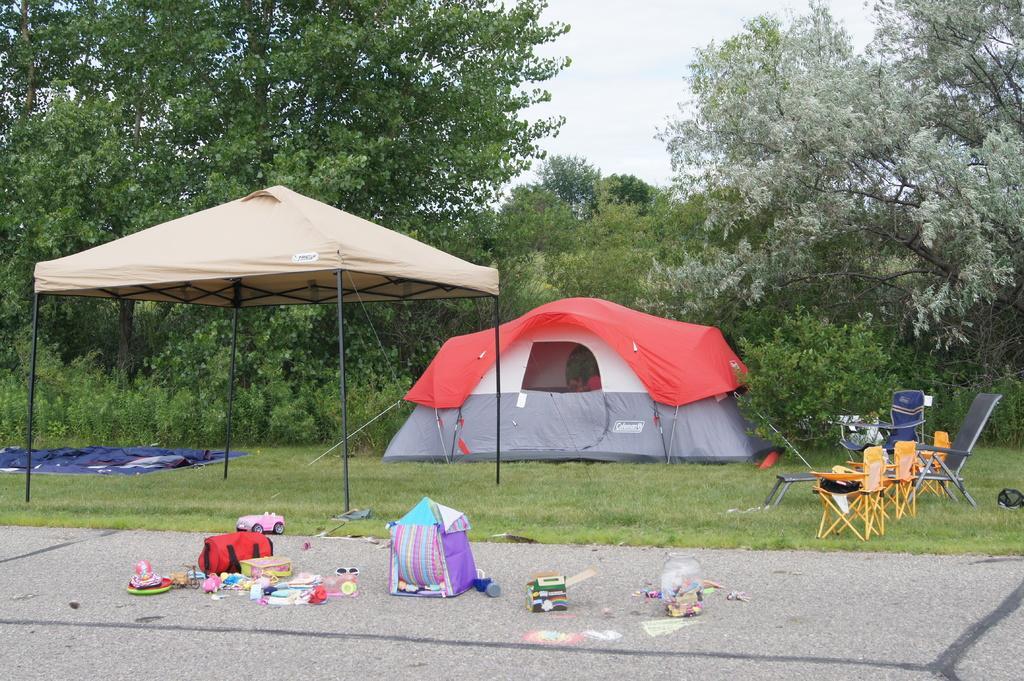How would you summarize this image in a sentence or two? In this image we can see tents, few chairs and few objects on the grass and few objects on the pavement and there are few trees and the sky in the background. 